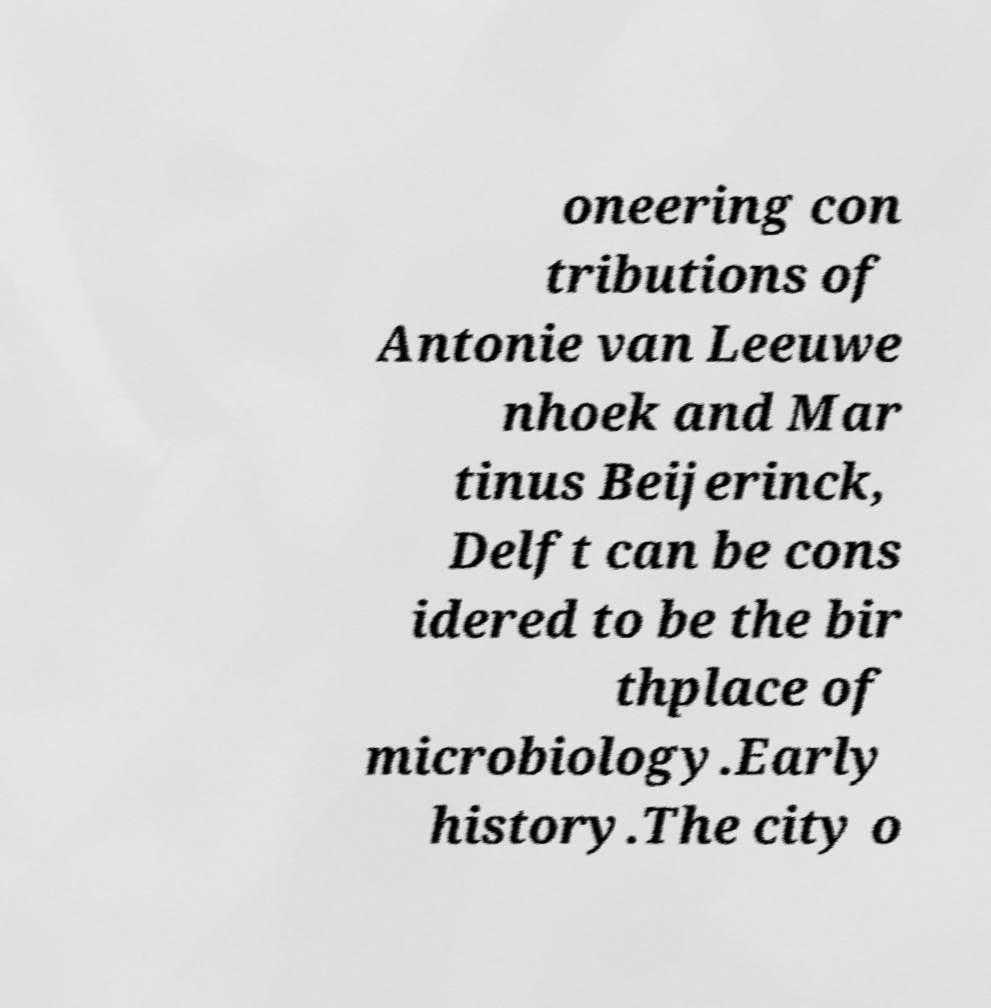There's text embedded in this image that I need extracted. Can you transcribe it verbatim? oneering con tributions of Antonie van Leeuwe nhoek and Mar tinus Beijerinck, Delft can be cons idered to be the bir thplace of microbiology.Early history.The city o 